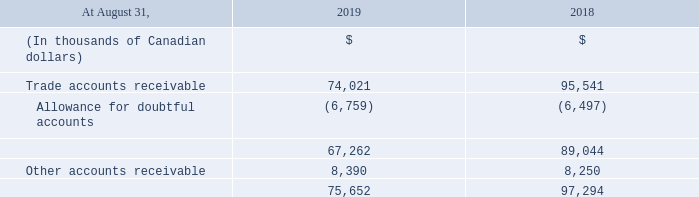The Corporation is also exposed to credit risk in relation to its trade accounts receivable. To mitigate such risk, the Corporation continuously monitors the financial condition of its customers and reviews the credit history or worthiness of each new large customer. The Corporation establishes an allowance for lifetime expected credit losses related to doubtful accounts. The doubtful accounts allowance is calculated on a specific-identification basis for larger customer accounts receivable and on a statistically derived basis for the remainder.
Factors such as the current economic conditions, forward-looking macroeconomic data and historical information (number of overdue days of the customer’s balance outstanding as well as the customer’s collection history) are examined. The Corporation believes that its allowance for doubtful accounts is sufficient to cover the related credit risk.
The Corporation has credit policies in place and has established various credit controls, including credit checks, deposits on accounts and advance billing, and has also established procedures to suspend the availability of services when customers have fully utilized approved credit limits or have violated existing payment terms. Since the Corporation has a large and diversified clientele dispersed throughout its market areas in Canada and the United States, there is no significant concentration of credit risk.
The following table provides further details on trade and other receivables, net of allowance for doubtful accounts:
What is the basis for the doubtful accounts receivable calculation? The doubtful accounts allowance is calculated on a specific-identification basis for larger customer accounts receivable and on a statistically derived basis for the remainder. What was the other accounts receivable in 2019?
Answer scale should be: thousand. 8,390. What is the trade accounts receivable in 2019?
Answer scale should be: thousand. 74,021. What is the increase / (decrease) in the trade accounts receivable from 2018 to 2019?
Answer scale should be: thousand. 74,021 - 95,541
Answer: -21520. What was the average allowance for doubtful accounts from 2018 to 2019?
Answer scale should be: thousand. -(6,759 + 6,497) / 2
Answer: -6628. What is the average other accounts receivable from 2018 to 2019?
Answer scale should be: thousand. (8,390 + 8,250) / 2
Answer: 8320. 